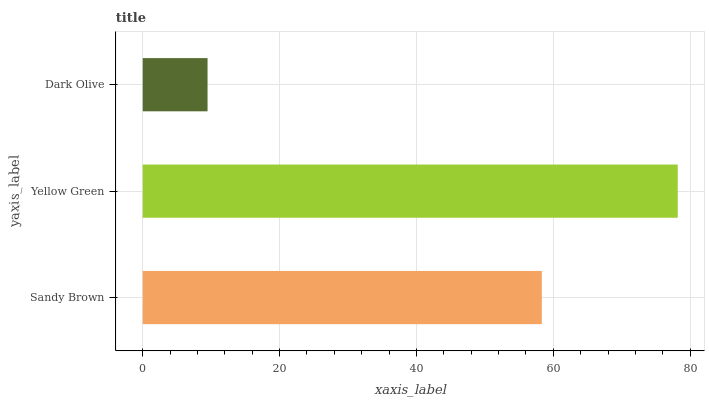Is Dark Olive the minimum?
Answer yes or no. Yes. Is Yellow Green the maximum?
Answer yes or no. Yes. Is Yellow Green the minimum?
Answer yes or no. No. Is Dark Olive the maximum?
Answer yes or no. No. Is Yellow Green greater than Dark Olive?
Answer yes or no. Yes. Is Dark Olive less than Yellow Green?
Answer yes or no. Yes. Is Dark Olive greater than Yellow Green?
Answer yes or no. No. Is Yellow Green less than Dark Olive?
Answer yes or no. No. Is Sandy Brown the high median?
Answer yes or no. Yes. Is Sandy Brown the low median?
Answer yes or no. Yes. Is Dark Olive the high median?
Answer yes or no. No. Is Dark Olive the low median?
Answer yes or no. No. 